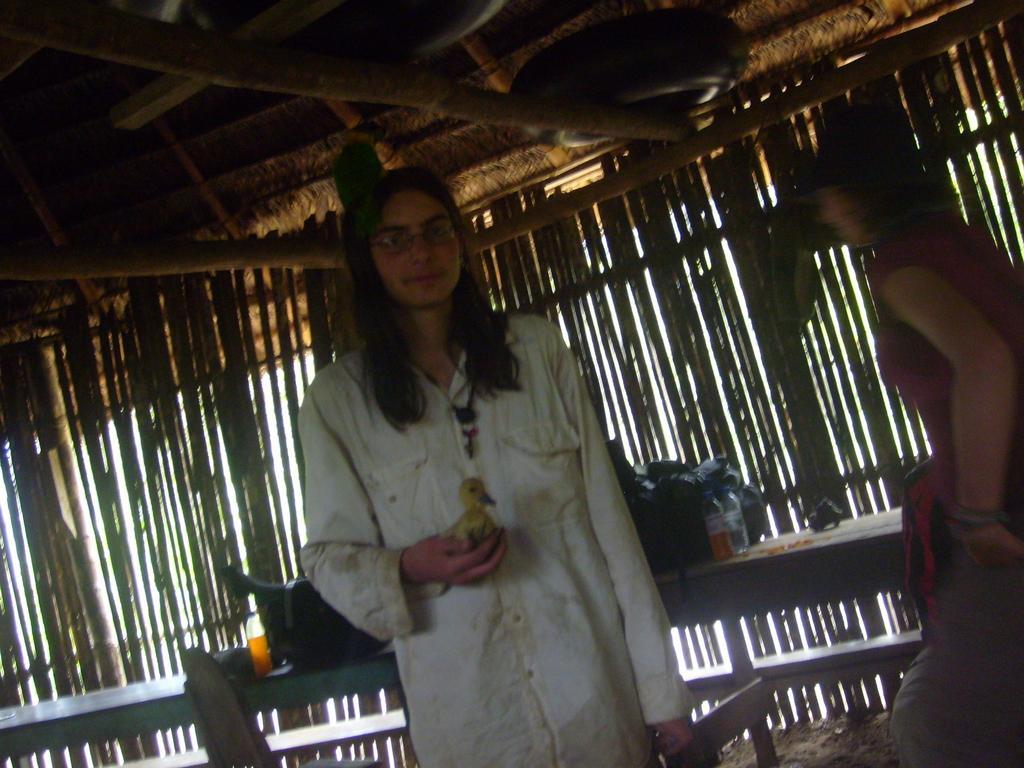Describe this image in one or two sentences. In this image there is a person holding a chicken in his hand, on the person's head there is a parrot, beside the person there is another person, in the background of the image there are chairs, wooden platform, on the platform there are some objects, behind the platform there are wooden sticks, at the top of the image there is a wooden rooftop supported with wooden logs and there is an object. 